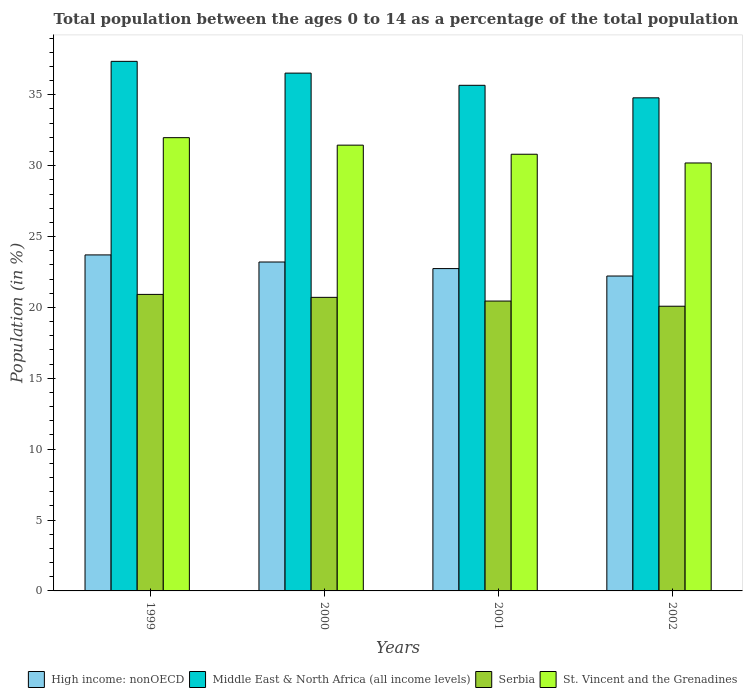How many different coloured bars are there?
Offer a terse response. 4. How many groups of bars are there?
Keep it short and to the point. 4. How many bars are there on the 4th tick from the left?
Provide a short and direct response. 4. How many bars are there on the 1st tick from the right?
Your response must be concise. 4. What is the percentage of the population ages 0 to 14 in Middle East & North Africa (all income levels) in 2002?
Give a very brief answer. 34.79. Across all years, what is the maximum percentage of the population ages 0 to 14 in High income: nonOECD?
Ensure brevity in your answer.  23.7. Across all years, what is the minimum percentage of the population ages 0 to 14 in High income: nonOECD?
Make the answer very short. 22.22. In which year was the percentage of the population ages 0 to 14 in Middle East & North Africa (all income levels) maximum?
Offer a terse response. 1999. In which year was the percentage of the population ages 0 to 14 in High income: nonOECD minimum?
Your answer should be compact. 2002. What is the total percentage of the population ages 0 to 14 in St. Vincent and the Grenadines in the graph?
Your answer should be very brief. 124.42. What is the difference between the percentage of the population ages 0 to 14 in Serbia in 2000 and that in 2001?
Keep it short and to the point. 0.26. What is the difference between the percentage of the population ages 0 to 14 in Serbia in 2000 and the percentage of the population ages 0 to 14 in High income: nonOECD in 2002?
Your answer should be compact. -1.51. What is the average percentage of the population ages 0 to 14 in Serbia per year?
Keep it short and to the point. 20.54. In the year 2001, what is the difference between the percentage of the population ages 0 to 14 in Middle East & North Africa (all income levels) and percentage of the population ages 0 to 14 in Serbia?
Ensure brevity in your answer.  15.22. What is the ratio of the percentage of the population ages 0 to 14 in High income: nonOECD in 1999 to that in 2001?
Your answer should be compact. 1.04. Is the percentage of the population ages 0 to 14 in Serbia in 1999 less than that in 2002?
Give a very brief answer. No. Is the difference between the percentage of the population ages 0 to 14 in Middle East & North Africa (all income levels) in 2001 and 2002 greater than the difference between the percentage of the population ages 0 to 14 in Serbia in 2001 and 2002?
Give a very brief answer. Yes. What is the difference between the highest and the second highest percentage of the population ages 0 to 14 in Serbia?
Provide a succinct answer. 0.21. What is the difference between the highest and the lowest percentage of the population ages 0 to 14 in High income: nonOECD?
Provide a succinct answer. 1.49. Is it the case that in every year, the sum of the percentage of the population ages 0 to 14 in High income: nonOECD and percentage of the population ages 0 to 14 in Middle East & North Africa (all income levels) is greater than the sum of percentage of the population ages 0 to 14 in Serbia and percentage of the population ages 0 to 14 in St. Vincent and the Grenadines?
Offer a terse response. Yes. What does the 1st bar from the left in 1999 represents?
Your answer should be very brief. High income: nonOECD. What does the 2nd bar from the right in 2001 represents?
Provide a succinct answer. Serbia. Is it the case that in every year, the sum of the percentage of the population ages 0 to 14 in High income: nonOECD and percentage of the population ages 0 to 14 in St. Vincent and the Grenadines is greater than the percentage of the population ages 0 to 14 in Serbia?
Give a very brief answer. Yes. How many bars are there?
Offer a terse response. 16. Are all the bars in the graph horizontal?
Offer a terse response. No. How many years are there in the graph?
Your answer should be very brief. 4. What is the difference between two consecutive major ticks on the Y-axis?
Ensure brevity in your answer.  5. Where does the legend appear in the graph?
Make the answer very short. Bottom right. What is the title of the graph?
Your answer should be compact. Total population between the ages 0 to 14 as a percentage of the total population. Does "Somalia" appear as one of the legend labels in the graph?
Provide a succinct answer. No. What is the label or title of the X-axis?
Provide a succinct answer. Years. What is the Population (in %) of High income: nonOECD in 1999?
Ensure brevity in your answer.  23.7. What is the Population (in %) of Middle East & North Africa (all income levels) in 1999?
Offer a very short reply. 37.36. What is the Population (in %) of Serbia in 1999?
Provide a succinct answer. 20.92. What is the Population (in %) in St. Vincent and the Grenadines in 1999?
Offer a terse response. 31.98. What is the Population (in %) in High income: nonOECD in 2000?
Give a very brief answer. 23.2. What is the Population (in %) of Middle East & North Africa (all income levels) in 2000?
Your answer should be very brief. 36.53. What is the Population (in %) of Serbia in 2000?
Provide a short and direct response. 20.71. What is the Population (in %) in St. Vincent and the Grenadines in 2000?
Give a very brief answer. 31.45. What is the Population (in %) in High income: nonOECD in 2001?
Offer a very short reply. 22.74. What is the Population (in %) of Middle East & North Africa (all income levels) in 2001?
Provide a short and direct response. 35.67. What is the Population (in %) of Serbia in 2001?
Your answer should be compact. 20.45. What is the Population (in %) in St. Vincent and the Grenadines in 2001?
Keep it short and to the point. 30.81. What is the Population (in %) of High income: nonOECD in 2002?
Offer a very short reply. 22.22. What is the Population (in %) in Middle East & North Africa (all income levels) in 2002?
Keep it short and to the point. 34.79. What is the Population (in %) of Serbia in 2002?
Make the answer very short. 20.08. What is the Population (in %) of St. Vincent and the Grenadines in 2002?
Ensure brevity in your answer.  30.19. Across all years, what is the maximum Population (in %) in High income: nonOECD?
Provide a succinct answer. 23.7. Across all years, what is the maximum Population (in %) in Middle East & North Africa (all income levels)?
Your answer should be very brief. 37.36. Across all years, what is the maximum Population (in %) in Serbia?
Your response must be concise. 20.92. Across all years, what is the maximum Population (in %) in St. Vincent and the Grenadines?
Your answer should be very brief. 31.98. Across all years, what is the minimum Population (in %) of High income: nonOECD?
Offer a very short reply. 22.22. Across all years, what is the minimum Population (in %) in Middle East & North Africa (all income levels)?
Make the answer very short. 34.79. Across all years, what is the minimum Population (in %) in Serbia?
Ensure brevity in your answer.  20.08. Across all years, what is the minimum Population (in %) in St. Vincent and the Grenadines?
Provide a succinct answer. 30.19. What is the total Population (in %) in High income: nonOECD in the graph?
Your response must be concise. 91.86. What is the total Population (in %) of Middle East & North Africa (all income levels) in the graph?
Give a very brief answer. 144.35. What is the total Population (in %) of Serbia in the graph?
Give a very brief answer. 82.16. What is the total Population (in %) of St. Vincent and the Grenadines in the graph?
Provide a succinct answer. 124.42. What is the difference between the Population (in %) in High income: nonOECD in 1999 and that in 2000?
Your answer should be compact. 0.5. What is the difference between the Population (in %) in Middle East & North Africa (all income levels) in 1999 and that in 2000?
Ensure brevity in your answer.  0.83. What is the difference between the Population (in %) in Serbia in 1999 and that in 2000?
Make the answer very short. 0.21. What is the difference between the Population (in %) in St. Vincent and the Grenadines in 1999 and that in 2000?
Your answer should be very brief. 0.53. What is the difference between the Population (in %) of High income: nonOECD in 1999 and that in 2001?
Make the answer very short. 0.96. What is the difference between the Population (in %) of Middle East & North Africa (all income levels) in 1999 and that in 2001?
Give a very brief answer. 1.69. What is the difference between the Population (in %) in Serbia in 1999 and that in 2001?
Your response must be concise. 0.47. What is the difference between the Population (in %) of St. Vincent and the Grenadines in 1999 and that in 2001?
Provide a succinct answer. 1.17. What is the difference between the Population (in %) of High income: nonOECD in 1999 and that in 2002?
Offer a terse response. 1.49. What is the difference between the Population (in %) of Middle East & North Africa (all income levels) in 1999 and that in 2002?
Provide a short and direct response. 2.57. What is the difference between the Population (in %) in Serbia in 1999 and that in 2002?
Make the answer very short. 0.83. What is the difference between the Population (in %) of St. Vincent and the Grenadines in 1999 and that in 2002?
Your response must be concise. 1.79. What is the difference between the Population (in %) in High income: nonOECD in 2000 and that in 2001?
Ensure brevity in your answer.  0.46. What is the difference between the Population (in %) in Middle East & North Africa (all income levels) in 2000 and that in 2001?
Offer a terse response. 0.86. What is the difference between the Population (in %) in Serbia in 2000 and that in 2001?
Provide a succinct answer. 0.26. What is the difference between the Population (in %) of St. Vincent and the Grenadines in 2000 and that in 2001?
Your answer should be compact. 0.64. What is the difference between the Population (in %) in High income: nonOECD in 2000 and that in 2002?
Provide a short and direct response. 0.99. What is the difference between the Population (in %) in Middle East & North Africa (all income levels) in 2000 and that in 2002?
Make the answer very short. 1.74. What is the difference between the Population (in %) in Serbia in 2000 and that in 2002?
Your answer should be very brief. 0.63. What is the difference between the Population (in %) in St. Vincent and the Grenadines in 2000 and that in 2002?
Give a very brief answer. 1.26. What is the difference between the Population (in %) of High income: nonOECD in 2001 and that in 2002?
Make the answer very short. 0.52. What is the difference between the Population (in %) in Middle East & North Africa (all income levels) in 2001 and that in 2002?
Your answer should be compact. 0.88. What is the difference between the Population (in %) of Serbia in 2001 and that in 2002?
Offer a terse response. 0.36. What is the difference between the Population (in %) in St. Vincent and the Grenadines in 2001 and that in 2002?
Offer a very short reply. 0.62. What is the difference between the Population (in %) in High income: nonOECD in 1999 and the Population (in %) in Middle East & North Africa (all income levels) in 2000?
Your response must be concise. -12.83. What is the difference between the Population (in %) of High income: nonOECD in 1999 and the Population (in %) of Serbia in 2000?
Ensure brevity in your answer.  2.99. What is the difference between the Population (in %) in High income: nonOECD in 1999 and the Population (in %) in St. Vincent and the Grenadines in 2000?
Ensure brevity in your answer.  -7.74. What is the difference between the Population (in %) of Middle East & North Africa (all income levels) in 1999 and the Population (in %) of Serbia in 2000?
Offer a very short reply. 16.65. What is the difference between the Population (in %) in Middle East & North Africa (all income levels) in 1999 and the Population (in %) in St. Vincent and the Grenadines in 2000?
Offer a very short reply. 5.91. What is the difference between the Population (in %) in Serbia in 1999 and the Population (in %) in St. Vincent and the Grenadines in 2000?
Offer a terse response. -10.53. What is the difference between the Population (in %) of High income: nonOECD in 1999 and the Population (in %) of Middle East & North Africa (all income levels) in 2001?
Your answer should be very brief. -11.97. What is the difference between the Population (in %) in High income: nonOECD in 1999 and the Population (in %) in Serbia in 2001?
Give a very brief answer. 3.26. What is the difference between the Population (in %) of High income: nonOECD in 1999 and the Population (in %) of St. Vincent and the Grenadines in 2001?
Provide a short and direct response. -7.1. What is the difference between the Population (in %) in Middle East & North Africa (all income levels) in 1999 and the Population (in %) in Serbia in 2001?
Offer a very short reply. 16.91. What is the difference between the Population (in %) of Middle East & North Africa (all income levels) in 1999 and the Population (in %) of St. Vincent and the Grenadines in 2001?
Offer a very short reply. 6.55. What is the difference between the Population (in %) in Serbia in 1999 and the Population (in %) in St. Vincent and the Grenadines in 2001?
Keep it short and to the point. -9.89. What is the difference between the Population (in %) of High income: nonOECD in 1999 and the Population (in %) of Middle East & North Africa (all income levels) in 2002?
Ensure brevity in your answer.  -11.08. What is the difference between the Population (in %) of High income: nonOECD in 1999 and the Population (in %) of Serbia in 2002?
Give a very brief answer. 3.62. What is the difference between the Population (in %) of High income: nonOECD in 1999 and the Population (in %) of St. Vincent and the Grenadines in 2002?
Keep it short and to the point. -6.49. What is the difference between the Population (in %) in Middle East & North Africa (all income levels) in 1999 and the Population (in %) in Serbia in 2002?
Provide a short and direct response. 17.28. What is the difference between the Population (in %) in Middle East & North Africa (all income levels) in 1999 and the Population (in %) in St. Vincent and the Grenadines in 2002?
Offer a terse response. 7.17. What is the difference between the Population (in %) of Serbia in 1999 and the Population (in %) of St. Vincent and the Grenadines in 2002?
Keep it short and to the point. -9.27. What is the difference between the Population (in %) of High income: nonOECD in 2000 and the Population (in %) of Middle East & North Africa (all income levels) in 2001?
Your response must be concise. -12.47. What is the difference between the Population (in %) of High income: nonOECD in 2000 and the Population (in %) of Serbia in 2001?
Your answer should be very brief. 2.76. What is the difference between the Population (in %) in High income: nonOECD in 2000 and the Population (in %) in St. Vincent and the Grenadines in 2001?
Your answer should be compact. -7.6. What is the difference between the Population (in %) in Middle East & North Africa (all income levels) in 2000 and the Population (in %) in Serbia in 2001?
Give a very brief answer. 16.08. What is the difference between the Population (in %) of Middle East & North Africa (all income levels) in 2000 and the Population (in %) of St. Vincent and the Grenadines in 2001?
Offer a very short reply. 5.72. What is the difference between the Population (in %) of Serbia in 2000 and the Population (in %) of St. Vincent and the Grenadines in 2001?
Your answer should be compact. -10.1. What is the difference between the Population (in %) in High income: nonOECD in 2000 and the Population (in %) in Middle East & North Africa (all income levels) in 2002?
Provide a short and direct response. -11.58. What is the difference between the Population (in %) of High income: nonOECD in 2000 and the Population (in %) of Serbia in 2002?
Offer a very short reply. 3.12. What is the difference between the Population (in %) in High income: nonOECD in 2000 and the Population (in %) in St. Vincent and the Grenadines in 2002?
Offer a very short reply. -6.99. What is the difference between the Population (in %) in Middle East & North Africa (all income levels) in 2000 and the Population (in %) in Serbia in 2002?
Offer a terse response. 16.45. What is the difference between the Population (in %) in Middle East & North Africa (all income levels) in 2000 and the Population (in %) in St. Vincent and the Grenadines in 2002?
Make the answer very short. 6.34. What is the difference between the Population (in %) in Serbia in 2000 and the Population (in %) in St. Vincent and the Grenadines in 2002?
Ensure brevity in your answer.  -9.48. What is the difference between the Population (in %) of High income: nonOECD in 2001 and the Population (in %) of Middle East & North Africa (all income levels) in 2002?
Ensure brevity in your answer.  -12.05. What is the difference between the Population (in %) in High income: nonOECD in 2001 and the Population (in %) in Serbia in 2002?
Keep it short and to the point. 2.66. What is the difference between the Population (in %) in High income: nonOECD in 2001 and the Population (in %) in St. Vincent and the Grenadines in 2002?
Your response must be concise. -7.45. What is the difference between the Population (in %) of Middle East & North Africa (all income levels) in 2001 and the Population (in %) of Serbia in 2002?
Your answer should be compact. 15.59. What is the difference between the Population (in %) of Middle East & North Africa (all income levels) in 2001 and the Population (in %) of St. Vincent and the Grenadines in 2002?
Ensure brevity in your answer.  5.48. What is the difference between the Population (in %) in Serbia in 2001 and the Population (in %) in St. Vincent and the Grenadines in 2002?
Your answer should be compact. -9.74. What is the average Population (in %) of High income: nonOECD per year?
Ensure brevity in your answer.  22.97. What is the average Population (in %) of Middle East & North Africa (all income levels) per year?
Make the answer very short. 36.09. What is the average Population (in %) in Serbia per year?
Provide a short and direct response. 20.54. What is the average Population (in %) in St. Vincent and the Grenadines per year?
Offer a terse response. 31.11. In the year 1999, what is the difference between the Population (in %) of High income: nonOECD and Population (in %) of Middle East & North Africa (all income levels)?
Your answer should be compact. -13.66. In the year 1999, what is the difference between the Population (in %) in High income: nonOECD and Population (in %) in Serbia?
Keep it short and to the point. 2.79. In the year 1999, what is the difference between the Population (in %) of High income: nonOECD and Population (in %) of St. Vincent and the Grenadines?
Provide a succinct answer. -8.27. In the year 1999, what is the difference between the Population (in %) in Middle East & North Africa (all income levels) and Population (in %) in Serbia?
Your answer should be compact. 16.44. In the year 1999, what is the difference between the Population (in %) of Middle East & North Africa (all income levels) and Population (in %) of St. Vincent and the Grenadines?
Offer a very short reply. 5.38. In the year 1999, what is the difference between the Population (in %) of Serbia and Population (in %) of St. Vincent and the Grenadines?
Make the answer very short. -11.06. In the year 2000, what is the difference between the Population (in %) in High income: nonOECD and Population (in %) in Middle East & North Africa (all income levels)?
Your response must be concise. -13.33. In the year 2000, what is the difference between the Population (in %) in High income: nonOECD and Population (in %) in Serbia?
Provide a short and direct response. 2.49. In the year 2000, what is the difference between the Population (in %) in High income: nonOECD and Population (in %) in St. Vincent and the Grenadines?
Ensure brevity in your answer.  -8.24. In the year 2000, what is the difference between the Population (in %) in Middle East & North Africa (all income levels) and Population (in %) in Serbia?
Keep it short and to the point. 15.82. In the year 2000, what is the difference between the Population (in %) in Middle East & North Africa (all income levels) and Population (in %) in St. Vincent and the Grenadines?
Your answer should be compact. 5.08. In the year 2000, what is the difference between the Population (in %) in Serbia and Population (in %) in St. Vincent and the Grenadines?
Your answer should be compact. -10.74. In the year 2001, what is the difference between the Population (in %) in High income: nonOECD and Population (in %) in Middle East & North Africa (all income levels)?
Offer a very short reply. -12.93. In the year 2001, what is the difference between the Population (in %) of High income: nonOECD and Population (in %) of Serbia?
Offer a very short reply. 2.29. In the year 2001, what is the difference between the Population (in %) in High income: nonOECD and Population (in %) in St. Vincent and the Grenadines?
Keep it short and to the point. -8.07. In the year 2001, what is the difference between the Population (in %) in Middle East & North Africa (all income levels) and Population (in %) in Serbia?
Offer a terse response. 15.22. In the year 2001, what is the difference between the Population (in %) in Middle East & North Africa (all income levels) and Population (in %) in St. Vincent and the Grenadines?
Offer a terse response. 4.86. In the year 2001, what is the difference between the Population (in %) of Serbia and Population (in %) of St. Vincent and the Grenadines?
Make the answer very short. -10.36. In the year 2002, what is the difference between the Population (in %) of High income: nonOECD and Population (in %) of Middle East & North Africa (all income levels)?
Give a very brief answer. -12.57. In the year 2002, what is the difference between the Population (in %) in High income: nonOECD and Population (in %) in Serbia?
Your answer should be compact. 2.13. In the year 2002, what is the difference between the Population (in %) of High income: nonOECD and Population (in %) of St. Vincent and the Grenadines?
Provide a short and direct response. -7.97. In the year 2002, what is the difference between the Population (in %) in Middle East & North Africa (all income levels) and Population (in %) in Serbia?
Make the answer very short. 14.7. In the year 2002, what is the difference between the Population (in %) of Middle East & North Africa (all income levels) and Population (in %) of St. Vincent and the Grenadines?
Keep it short and to the point. 4.6. In the year 2002, what is the difference between the Population (in %) of Serbia and Population (in %) of St. Vincent and the Grenadines?
Make the answer very short. -10.11. What is the ratio of the Population (in %) in High income: nonOECD in 1999 to that in 2000?
Provide a succinct answer. 1.02. What is the ratio of the Population (in %) in Middle East & North Africa (all income levels) in 1999 to that in 2000?
Offer a very short reply. 1.02. What is the ratio of the Population (in %) in St. Vincent and the Grenadines in 1999 to that in 2000?
Offer a terse response. 1.02. What is the ratio of the Population (in %) of High income: nonOECD in 1999 to that in 2001?
Give a very brief answer. 1.04. What is the ratio of the Population (in %) in Middle East & North Africa (all income levels) in 1999 to that in 2001?
Your answer should be very brief. 1.05. What is the ratio of the Population (in %) in St. Vincent and the Grenadines in 1999 to that in 2001?
Your response must be concise. 1.04. What is the ratio of the Population (in %) in High income: nonOECD in 1999 to that in 2002?
Provide a short and direct response. 1.07. What is the ratio of the Population (in %) of Middle East & North Africa (all income levels) in 1999 to that in 2002?
Make the answer very short. 1.07. What is the ratio of the Population (in %) of Serbia in 1999 to that in 2002?
Give a very brief answer. 1.04. What is the ratio of the Population (in %) of St. Vincent and the Grenadines in 1999 to that in 2002?
Provide a succinct answer. 1.06. What is the ratio of the Population (in %) of High income: nonOECD in 2000 to that in 2001?
Offer a terse response. 1.02. What is the ratio of the Population (in %) in Middle East & North Africa (all income levels) in 2000 to that in 2001?
Ensure brevity in your answer.  1.02. What is the ratio of the Population (in %) in Serbia in 2000 to that in 2001?
Provide a short and direct response. 1.01. What is the ratio of the Population (in %) in St. Vincent and the Grenadines in 2000 to that in 2001?
Your answer should be compact. 1.02. What is the ratio of the Population (in %) in High income: nonOECD in 2000 to that in 2002?
Your response must be concise. 1.04. What is the ratio of the Population (in %) of Middle East & North Africa (all income levels) in 2000 to that in 2002?
Your answer should be compact. 1.05. What is the ratio of the Population (in %) of Serbia in 2000 to that in 2002?
Ensure brevity in your answer.  1.03. What is the ratio of the Population (in %) of St. Vincent and the Grenadines in 2000 to that in 2002?
Your answer should be very brief. 1.04. What is the ratio of the Population (in %) in High income: nonOECD in 2001 to that in 2002?
Keep it short and to the point. 1.02. What is the ratio of the Population (in %) of Middle East & North Africa (all income levels) in 2001 to that in 2002?
Ensure brevity in your answer.  1.03. What is the ratio of the Population (in %) in Serbia in 2001 to that in 2002?
Provide a short and direct response. 1.02. What is the ratio of the Population (in %) of St. Vincent and the Grenadines in 2001 to that in 2002?
Make the answer very short. 1.02. What is the difference between the highest and the second highest Population (in %) in Middle East & North Africa (all income levels)?
Your answer should be compact. 0.83. What is the difference between the highest and the second highest Population (in %) of Serbia?
Your response must be concise. 0.21. What is the difference between the highest and the second highest Population (in %) in St. Vincent and the Grenadines?
Your answer should be compact. 0.53. What is the difference between the highest and the lowest Population (in %) in High income: nonOECD?
Give a very brief answer. 1.49. What is the difference between the highest and the lowest Population (in %) in Middle East & North Africa (all income levels)?
Make the answer very short. 2.57. What is the difference between the highest and the lowest Population (in %) of Serbia?
Your answer should be very brief. 0.83. What is the difference between the highest and the lowest Population (in %) of St. Vincent and the Grenadines?
Keep it short and to the point. 1.79. 